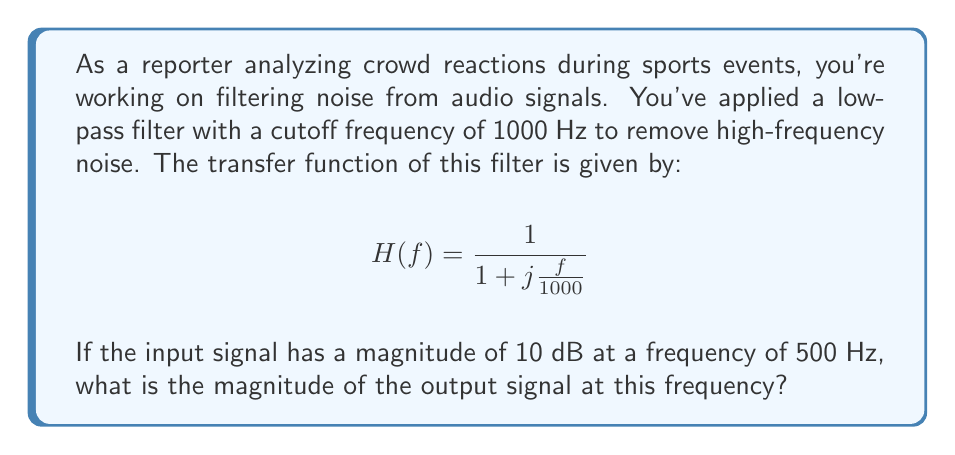Provide a solution to this math problem. To solve this problem, we need to follow these steps:

1) First, we need to calculate the magnitude response of the filter at 500 Hz. The magnitude response is given by the absolute value of the transfer function:

   $$|H(f)| = \frac{1}{\sqrt{1 + (\frac{f}{1000})^2}}$$

2) Substituting f = 500 Hz:

   $$|H(500)| = \frac{1}{\sqrt{1 + (\frac{500}{1000})^2}} = \frac{1}{\sqrt{1 + 0.25}} = \frac{1}{\sqrt{1.25}} = \frac{1}{1.118} = 0.894$$

3) The magnitude response in decibels is:

   $$20 \log_{10}(0.894) = -0.97 \text{ dB}$$

4) This means the filter attenuates the signal by 0.97 dB at 500 Hz.

5) The input signal has a magnitude of 10 dB. To find the output magnitude, we subtract the filter's attenuation:

   $$10 \text{ dB} - 0.97 \text{ dB} = 9.03 \text{ dB}$$

Therefore, the magnitude of the output signal at 500 Hz is 9.03 dB.
Answer: 9.03 dB 